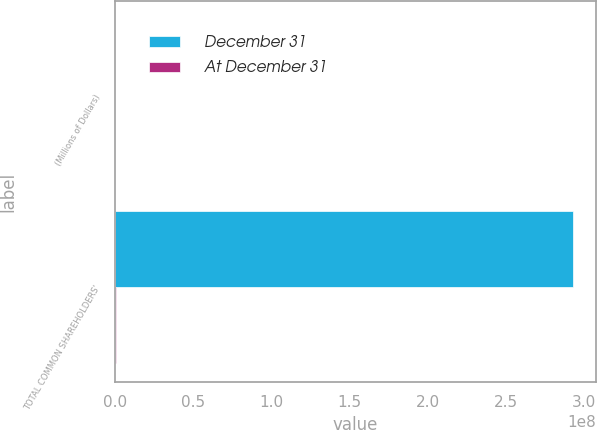Convert chart. <chart><loc_0><loc_0><loc_500><loc_500><stacked_bar_chart><ecel><fcel>(Millions of Dollars)<fcel>TOTAL COMMON SHAREHOLDERS'<nl><fcel>December 31<fcel>2013<fcel>2.92872e+08<nl><fcel>At December 31<fcel>2013<fcel>12270<nl></chart> 